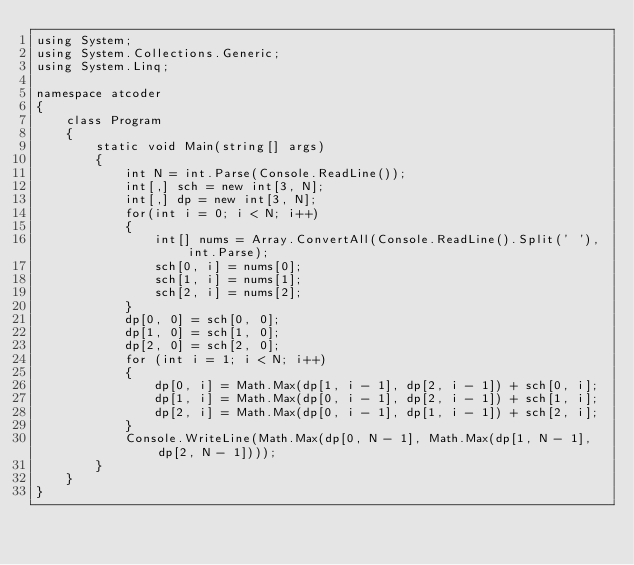Convert code to text. <code><loc_0><loc_0><loc_500><loc_500><_C#_>using System;
using System.Collections.Generic;
using System.Linq;

namespace atcoder
{
    class Program
    {
        static void Main(string[] args)
        {
            int N = int.Parse(Console.ReadLine());
            int[,] sch = new int[3, N];
            int[,] dp = new int[3, N];
            for(int i = 0; i < N; i++)
            {
                int[] nums = Array.ConvertAll(Console.ReadLine().Split(' '), int.Parse);
                sch[0, i] = nums[0];
                sch[1, i] = nums[1];
                sch[2, i] = nums[2];
            }
            dp[0, 0] = sch[0, 0];
            dp[1, 0] = sch[1, 0];
            dp[2, 0] = sch[2, 0];
            for (int i = 1; i < N; i++)
            {
                dp[0, i] = Math.Max(dp[1, i - 1], dp[2, i - 1]) + sch[0, i];
                dp[1, i] = Math.Max(dp[0, i - 1], dp[2, i - 1]) + sch[1, i];
                dp[2, i] = Math.Max(dp[0, i - 1], dp[1, i - 1]) + sch[2, i];
            }
            Console.WriteLine(Math.Max(dp[0, N - 1], Math.Max(dp[1, N - 1], dp[2, N - 1])));
        }
    }
}</code> 